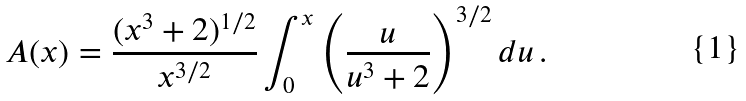Convert formula to latex. <formula><loc_0><loc_0><loc_500><loc_500>A ( x ) = \frac { ( x ^ { 3 } + 2 ) ^ { 1 / 2 } } { x ^ { 3 / 2 } } \int _ { 0 } ^ { x } \left ( \frac { u } { u ^ { 3 } + 2 } \right ) ^ { 3 / 2 } d u \, .</formula> 